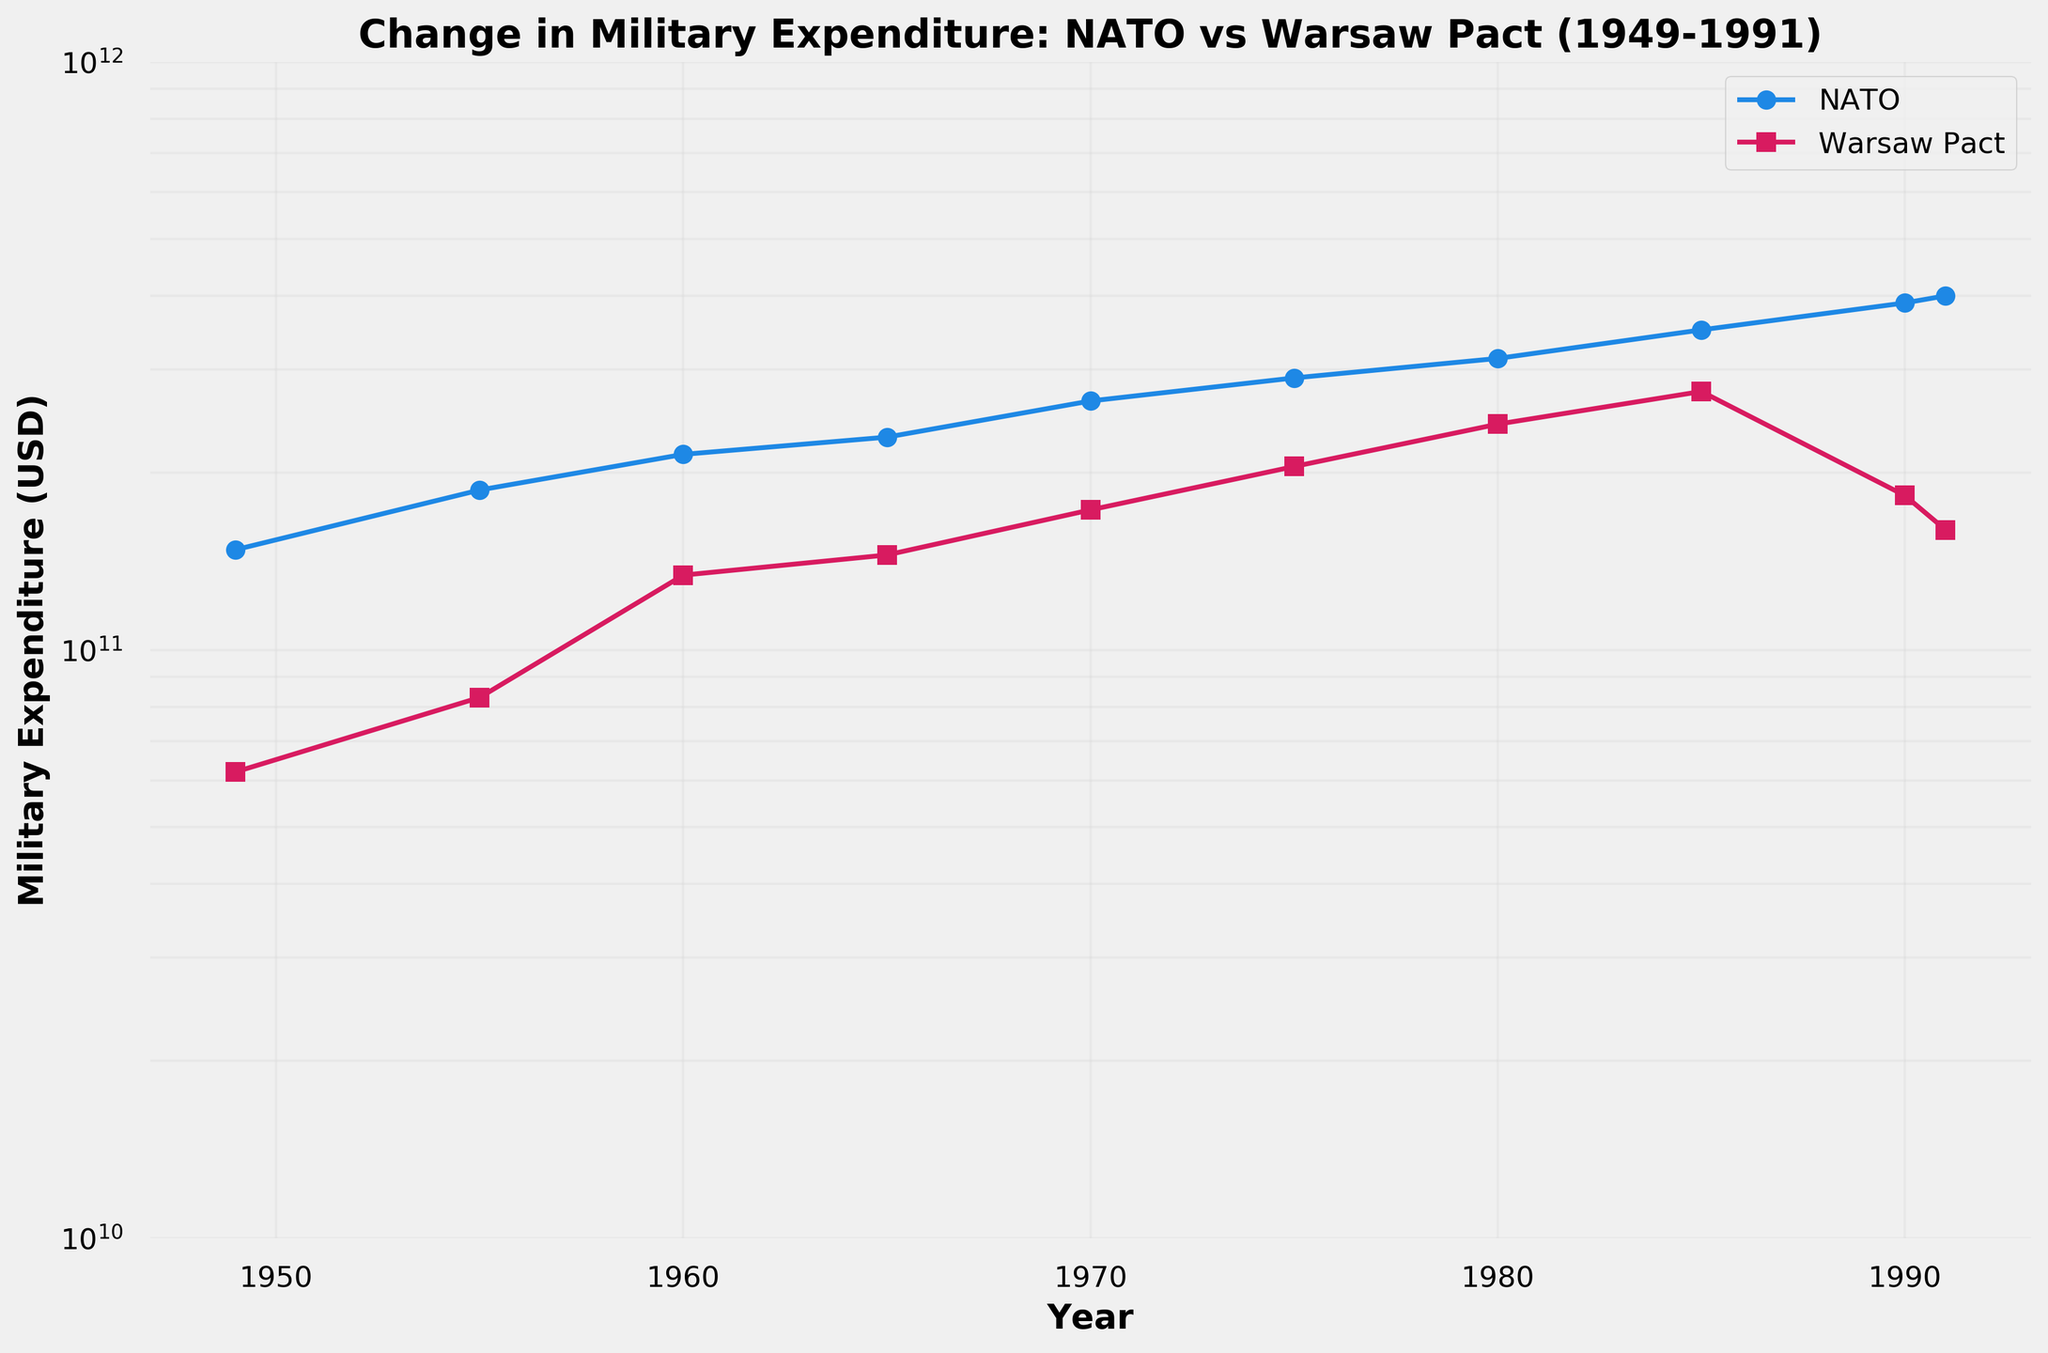question: What is the title of the figure? explanation: The title of the figure is typically found at the top, providing a summary of what the figure represents.
Answer: Change in Military Expenditure: NATO vs Warsaw Pact (1949-1991) question: How many times does the data plot the military expenditure for NATO and Warsaw Pact countries? explanation: By looking at the number of markers (points) on the figure, we can count the frequency at which the data is plotted.
Answer: 10 question: Which joint has the higher military expenditure in 1949, NATO or Warsaw Pact? explanation: Compare the markers at the year 1949 on the figure for both NATO and Warsaw Pact. NATO's expenditure is higher than Warsaw Pact's expenditure.
Answer: NATO question: What is the trend in NATO's military expenditure from 1949 to 1991? explanation: Observing the line plot for NATO over the years, the expenditures consistently show an upwards trend from 1949 to 1991, with some fluctuations.
Answer: Increasing question: Between which years does NATO see the largest increase in military expenditure? explanation: By looking at the NATO plot, identify the years with the steepest slope indicating the largest increase. The largest increase occurs between 1985 and 1990.
Answer: 1985-1990 question: What was the military expenditure difference between NATO and Warsaw Pact in 1985? explanation: Locate the military expenditure values for NATO and Warsaw Pact in 1985 on the plot, then subtract to find the difference. NATO: $350 billion, Warsaw Pact: $275 billion. The difference is $350B - $275B = $75B
Answer: $75 billion question: During which year did Warsaw Pact expediture peak? explanation: Locate the point on Warsaw Pact line plot with the highest military expenditure value.
Answer: 1985 question: Did Warsaw Pact or NATO see a reduction in military expenditure between 1990 and 1991? explanation: Compare both lines between 1990 and 1991 to see if the plot goes downward. NATO continues to increase while Warsaw Pact decreases.
Answer: Warsaw Pact question: Which year has the closest military expenditure between NATO and Warsaw Pact? explanation: Look for the points at which the NATO and Warsaw Pact expenditure lines are closest to each other. Observing the plot, they are closest around 1965.
Answer: 1965 question: What is the pattern of grid lines on the figure? explanation: The plot has logarithmic y-scale with grid lines covering both minor and major ticks, lightly visible across the plot.
Answer: Logarithmic with grid lines 